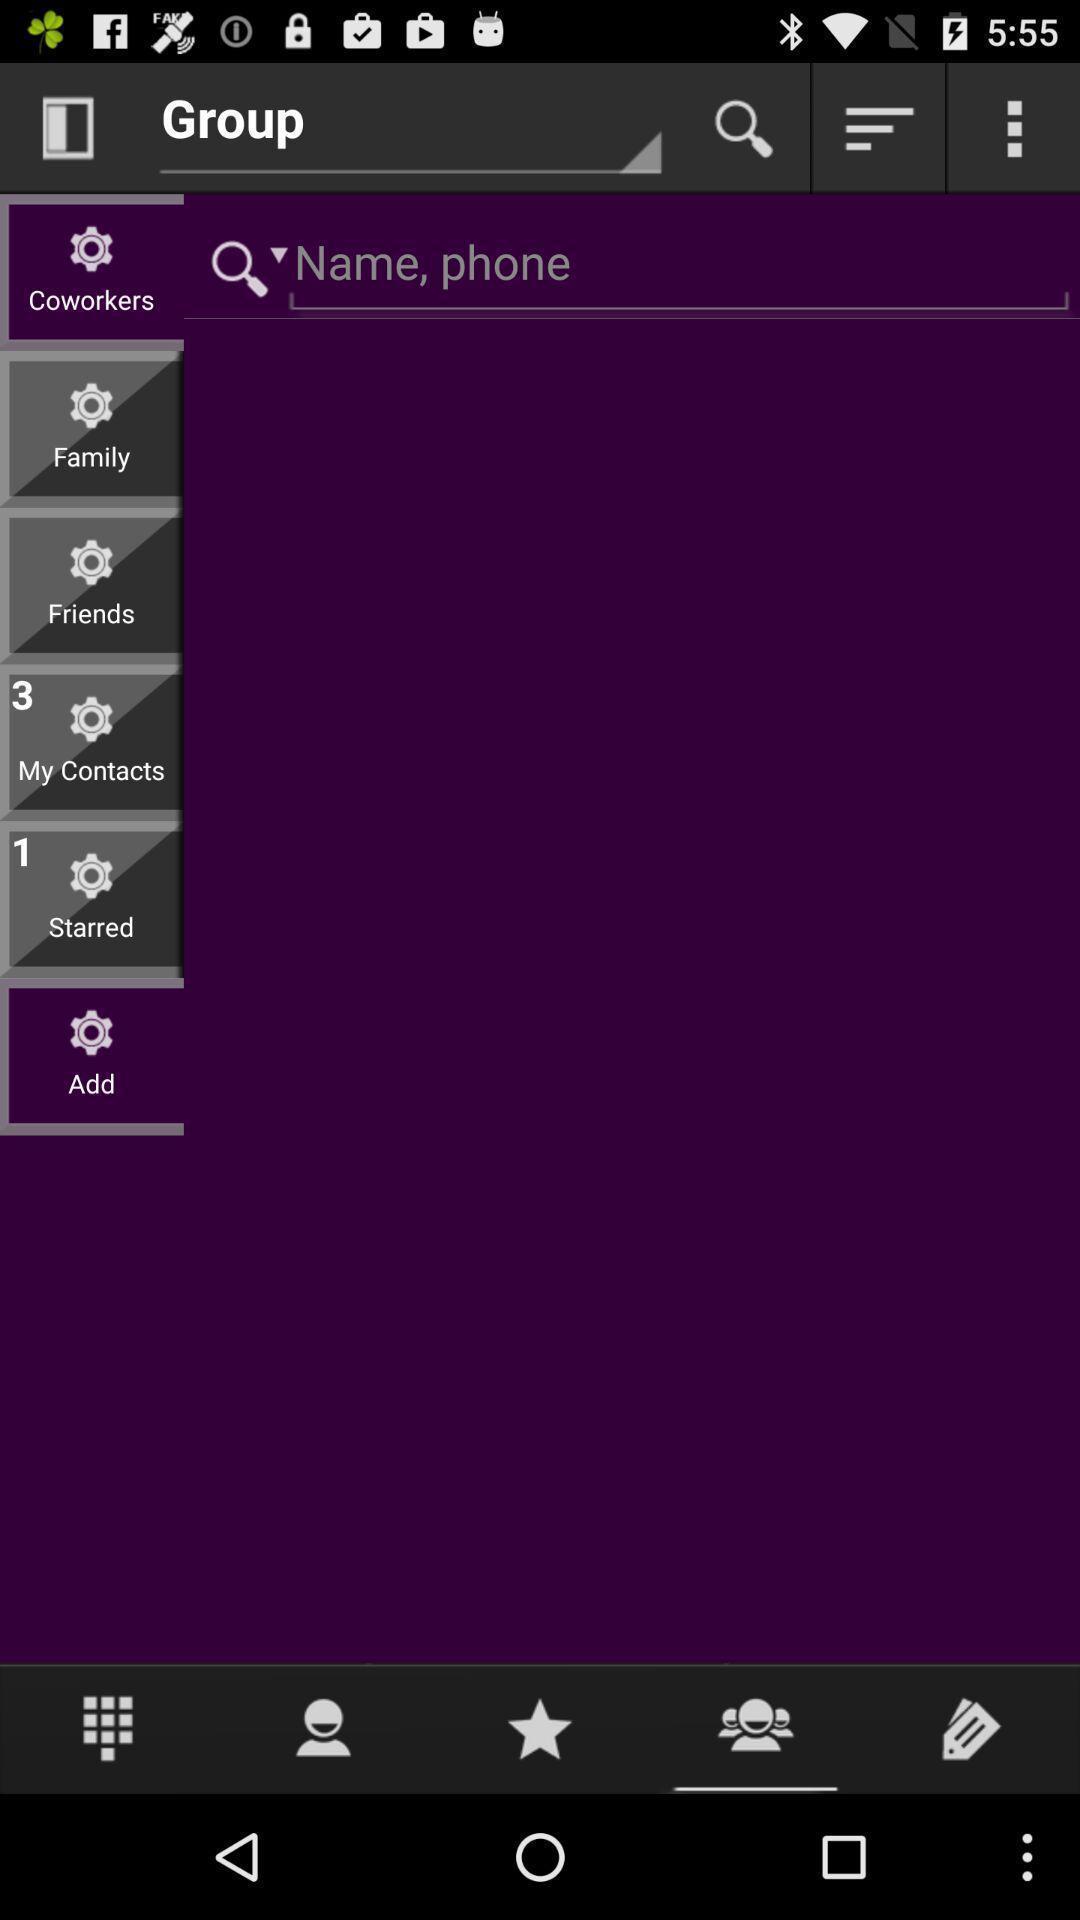Explain the elements present in this screenshot. Search page for contacts in mobile. 